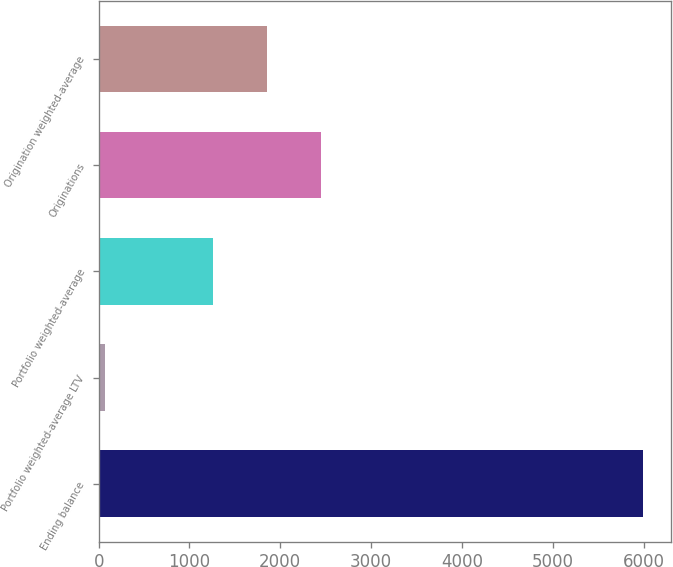<chart> <loc_0><loc_0><loc_500><loc_500><bar_chart><fcel>Ending balance<fcel>Portfolio weighted-average LTV<fcel>Portfolio weighted-average<fcel>Originations<fcel>Origination weighted-average<nl><fcel>5998<fcel>75<fcel>1259.6<fcel>2444.2<fcel>1851.9<nl></chart> 